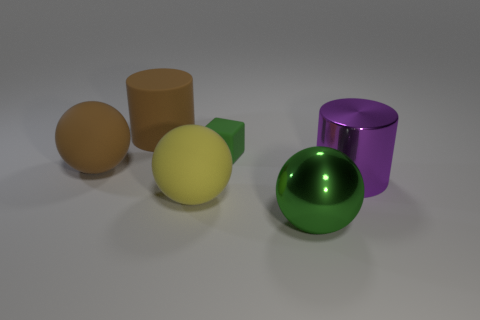What size is the green thing that is made of the same material as the big purple cylinder?
Make the answer very short. Large. What number of cyan things are either metallic spheres or big balls?
Ensure brevity in your answer.  0. How many big purple metal cylinders are in front of the big brown rubber cylinder to the left of the large yellow thing?
Provide a succinct answer. 1. Are there more large purple metallic cylinders to the left of the tiny green matte cube than large green shiny spheres that are to the left of the big metallic sphere?
Your response must be concise. No. What is the green cube made of?
Give a very brief answer. Rubber. Are there any cyan rubber blocks of the same size as the purple cylinder?
Provide a succinct answer. No. What is the material of the brown thing that is the same size as the brown ball?
Provide a succinct answer. Rubber. How many cyan shiny things are there?
Ensure brevity in your answer.  0. There is a brown sphere to the left of the shiny ball; what size is it?
Ensure brevity in your answer.  Large. Is the number of large things in front of the large rubber cylinder the same as the number of small red rubber blocks?
Offer a terse response. No. 